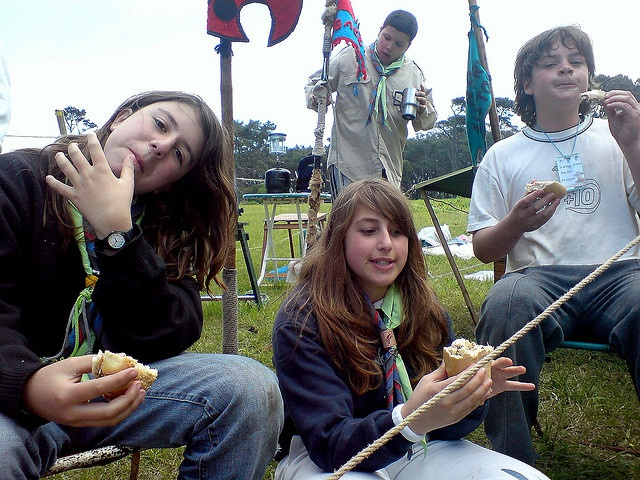Describe the objects in this image and their specific colors. I can see people in white, black, gray, darkgray, and navy tones, people in white, black, gray, and maroon tones, people in white, gray, black, darkgray, and lightgray tones, people in white, gray, darkgray, and lightgray tones, and dining table in white, olive, gray, darkgray, and ivory tones in this image. 